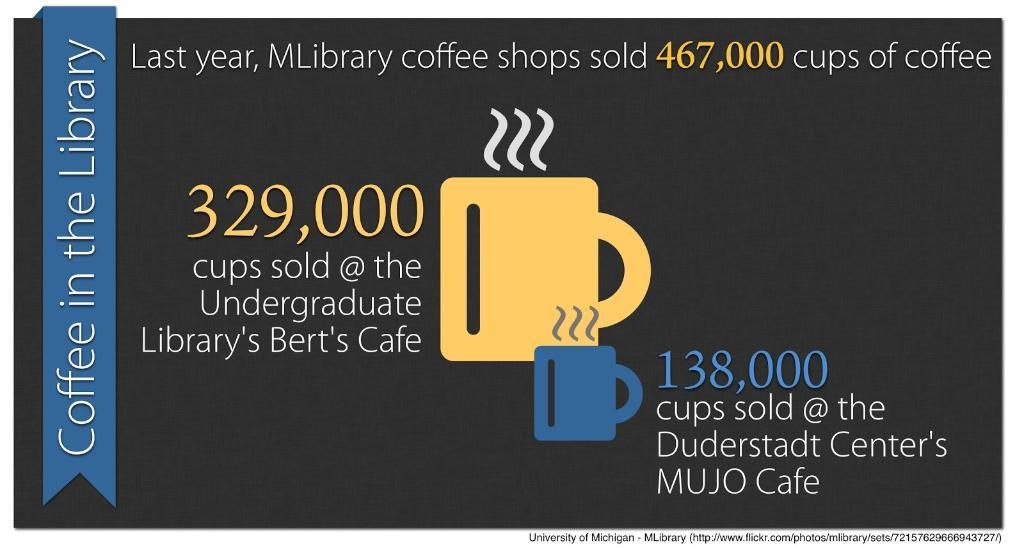<image>
Present a compact description of the photo's key features. Poster that says "Coffee in the Library" on the side. 